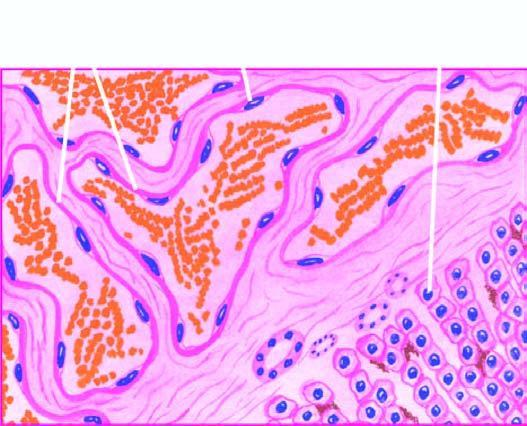what is seen between the cavernous spaces?
Answer the question using a single word or phrase. Scanty connective tissue stroma 